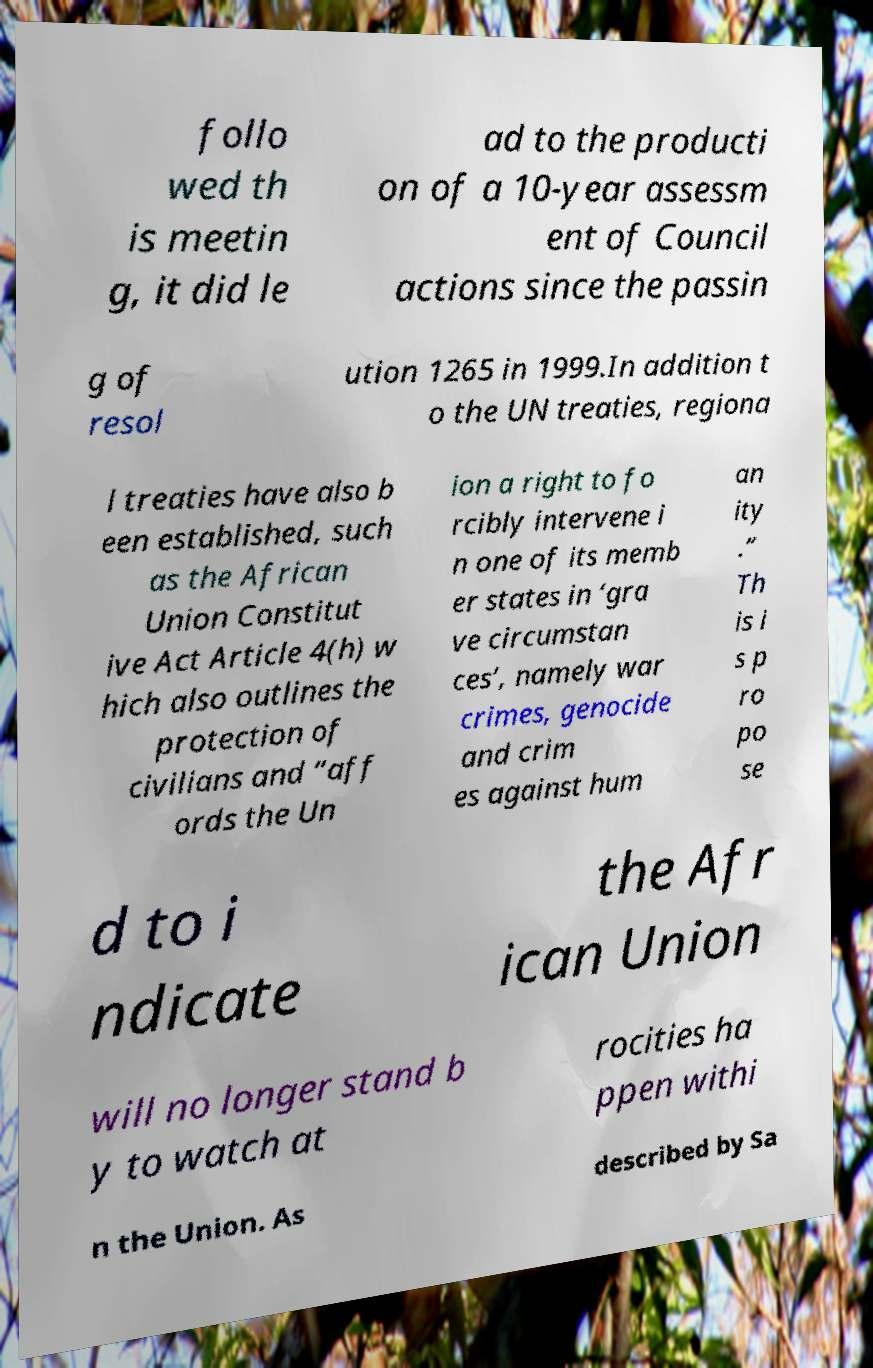Can you accurately transcribe the text from the provided image for me? follo wed th is meetin g, it did le ad to the producti on of a 10-year assessm ent of Council actions since the passin g of resol ution 1265 in 1999.In addition t o the UN treaties, regiona l treaties have also b een established, such as the African Union Constitut ive Act Article 4(h) w hich also outlines the protection of civilians and “aff ords the Un ion a right to fo rcibly intervene i n one of its memb er states in ‘gra ve circumstan ces’, namely war crimes, genocide and crim es against hum an ity .” Th is i s p ro po se d to i ndicate the Afr ican Union will no longer stand b y to watch at rocities ha ppen withi n the Union. As described by Sa 